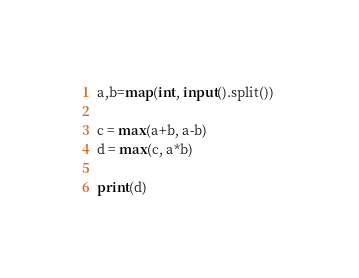<code> <loc_0><loc_0><loc_500><loc_500><_Python_>a,b=map(int, input().split()) 

c = max(a+b, a-b)
d = max(c, a*b)

print(d)</code> 